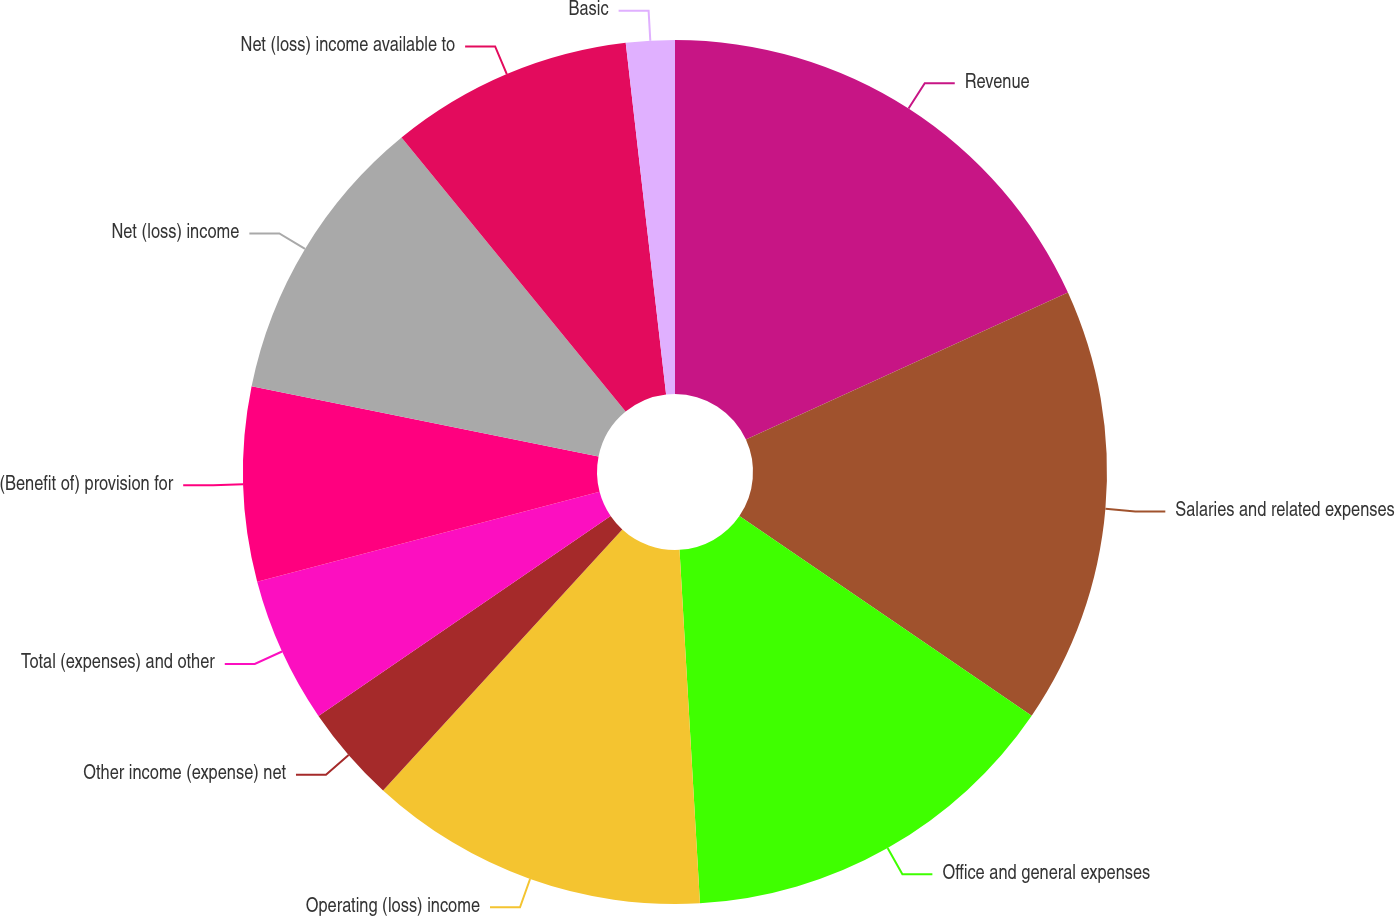Convert chart to OTSL. <chart><loc_0><loc_0><loc_500><loc_500><pie_chart><fcel>Revenue<fcel>Salaries and related expenses<fcel>Office and general expenses<fcel>Operating (loss) income<fcel>Other income (expense) net<fcel>Total (expenses) and other<fcel>(Benefit of) provision for<fcel>Net (loss) income<fcel>Net (loss) income available to<fcel>Basic<nl><fcel>18.18%<fcel>16.36%<fcel>14.54%<fcel>12.73%<fcel>3.64%<fcel>5.46%<fcel>7.27%<fcel>10.91%<fcel>9.09%<fcel>1.82%<nl></chart> 